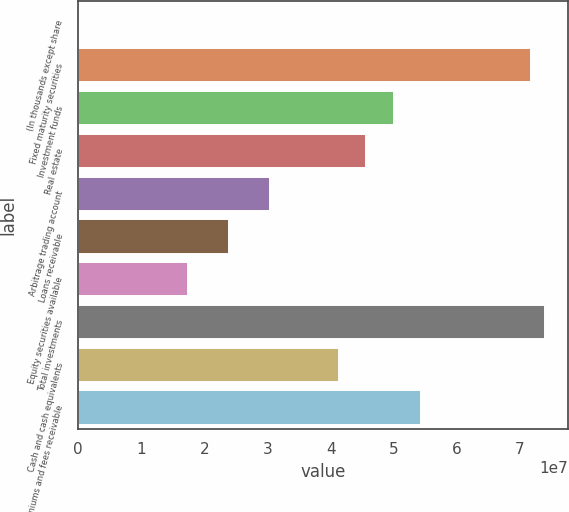Convert chart. <chart><loc_0><loc_0><loc_500><loc_500><bar_chart><fcel>(In thousands except share<fcel>Fixed maturity securities<fcel>Investment funds<fcel>Real estate<fcel>Arbitrage trading account<fcel>Loans receivable<fcel>Equity securities available<fcel>Total investments<fcel>Cash and cash equivalents<fcel>Premiums and fees receivable<nl><fcel>2015<fcel>7.17076e+07<fcel>4.99786e+07<fcel>4.56328e+07<fcel>3.04225e+07<fcel>2.39039e+07<fcel>1.73852e+07<fcel>7.38805e+07<fcel>4.1287e+07<fcel>5.43244e+07<nl></chart> 